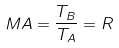<formula> <loc_0><loc_0><loc_500><loc_500>M A = \frac { T _ { B } } { T _ { A } } = R</formula> 